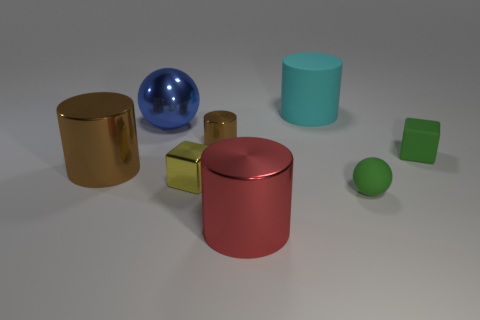Is the large red metal object the same shape as the large brown shiny object?
Offer a very short reply. Yes. How big is the green object that is in front of the green matte block right of the brown shiny cylinder that is left of the blue sphere?
Your response must be concise. Small. What material is the big sphere?
Offer a very short reply. Metal. What is the size of the object that is the same color as the tiny matte ball?
Keep it short and to the point. Small. Do the red object and the metal thing to the left of the shiny ball have the same shape?
Offer a terse response. Yes. There is a ball behind the sphere to the right of the large cylinder that is in front of the yellow metal thing; what is it made of?
Your answer should be compact. Metal. How many large blue balls are there?
Make the answer very short. 1. What number of yellow objects are big metallic objects or rubber things?
Ensure brevity in your answer.  0. What number of other things are the same shape as the large brown object?
Your response must be concise. 3. Do the big shiny cylinder on the left side of the big metallic ball and the small metallic thing behind the rubber cube have the same color?
Provide a short and direct response. Yes. 